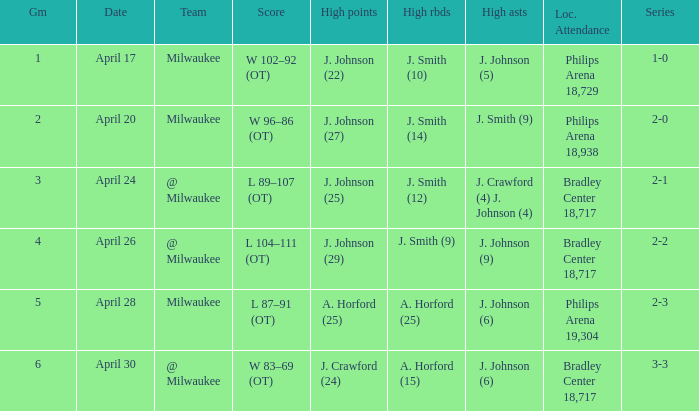What were the amount of rebounds in game 2? J. Smith (14). 